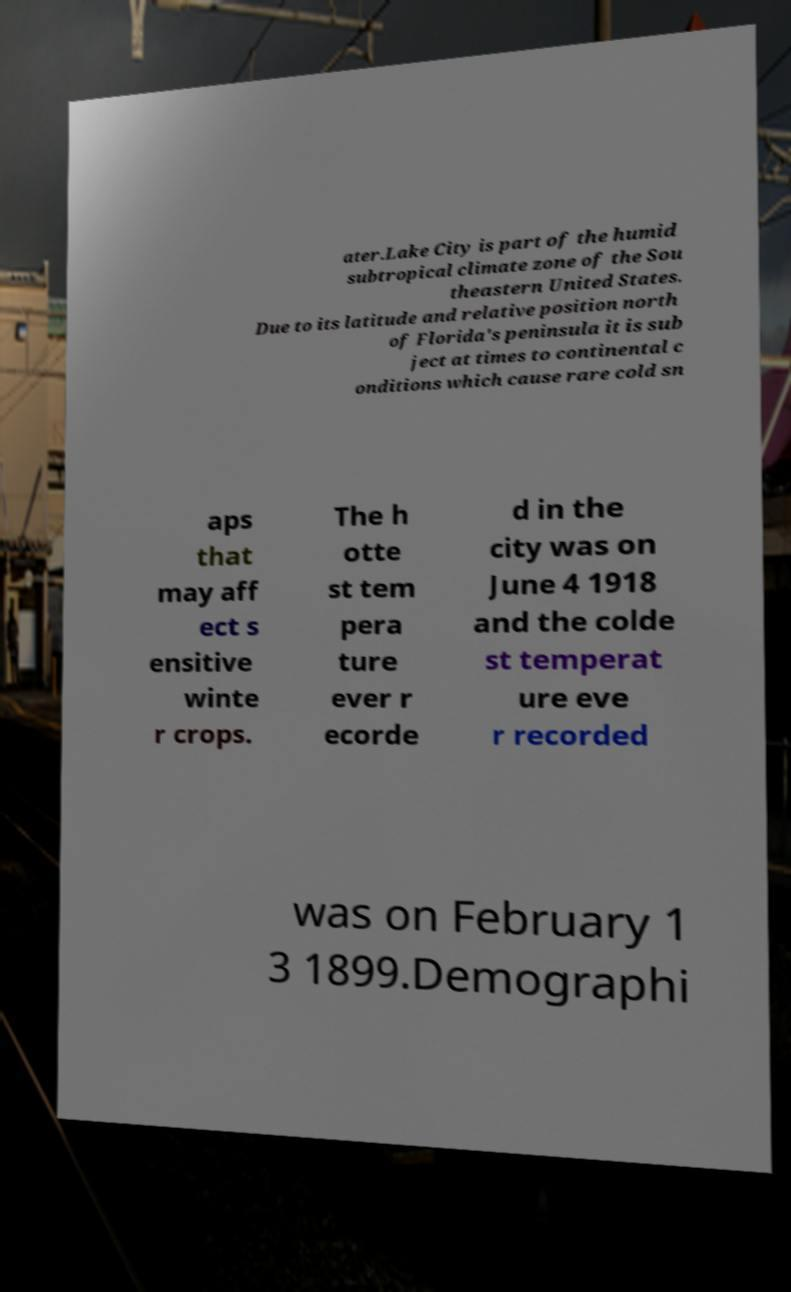Please read and relay the text visible in this image. What does it say? ater.Lake City is part of the humid subtropical climate zone of the Sou theastern United States. Due to its latitude and relative position north of Florida's peninsula it is sub ject at times to continental c onditions which cause rare cold sn aps that may aff ect s ensitive winte r crops. The h otte st tem pera ture ever r ecorde d in the city was on June 4 1918 and the colde st temperat ure eve r recorded was on February 1 3 1899.Demographi 